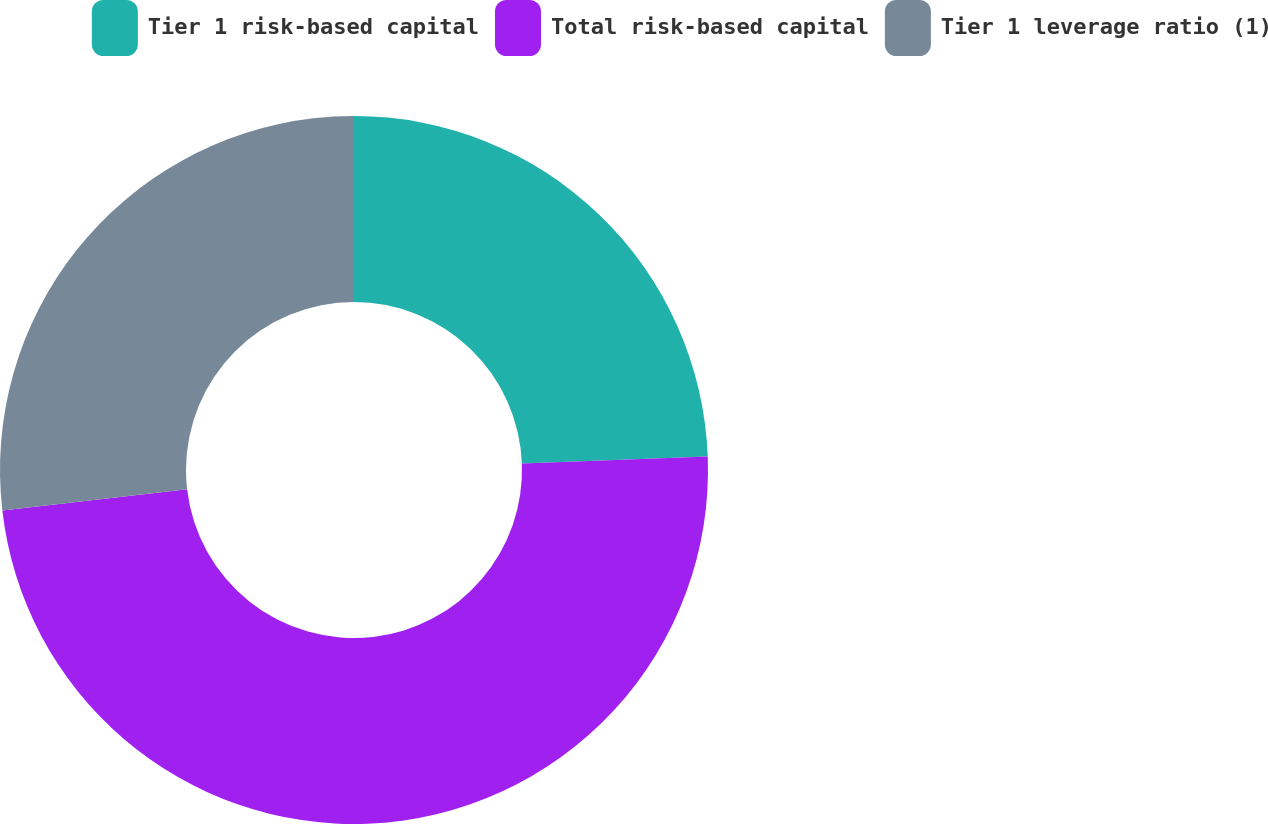<chart> <loc_0><loc_0><loc_500><loc_500><pie_chart><fcel>Tier 1 risk-based capital<fcel>Total risk-based capital<fcel>Tier 1 leverage ratio (1)<nl><fcel>24.39%<fcel>48.78%<fcel>26.83%<nl></chart> 